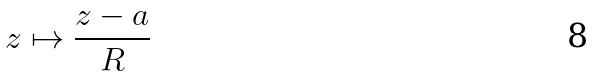<formula> <loc_0><loc_0><loc_500><loc_500>z \mapsto \frac { z - a } { R }</formula> 